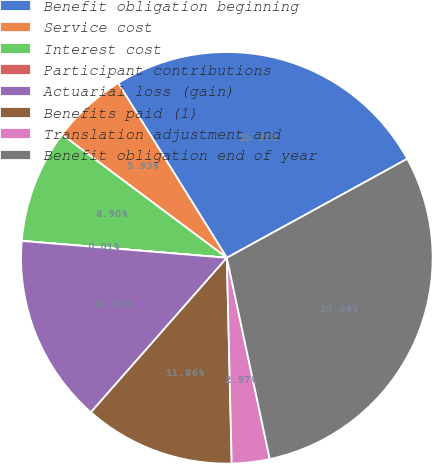Convert chart. <chart><loc_0><loc_0><loc_500><loc_500><pie_chart><fcel>Benefit obligation beginning<fcel>Service cost<fcel>Interest cost<fcel>Participant contributions<fcel>Actuarial loss (gain)<fcel>Benefits paid (1)<fcel>Translation adjustment and<fcel>Benefit obligation end of year<nl><fcel>25.87%<fcel>5.93%<fcel>8.9%<fcel>0.01%<fcel>14.82%<fcel>11.86%<fcel>2.97%<fcel>29.64%<nl></chart> 